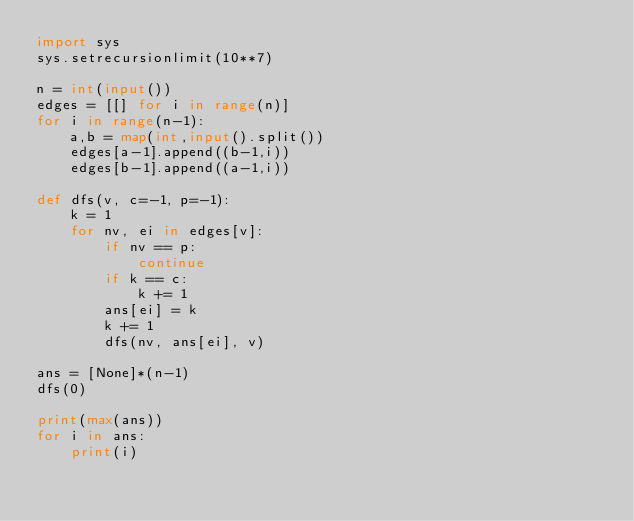Convert code to text. <code><loc_0><loc_0><loc_500><loc_500><_Python_>import sys
sys.setrecursionlimit(10**7)

n = int(input())
edges = [[] for i in range(n)]
for i in range(n-1):
    a,b = map(int,input().split())
    edges[a-1].append((b-1,i))
    edges[b-1].append((a-1,i))

def dfs(v, c=-1, p=-1):
    k = 1
    for nv, ei in edges[v]:
        if nv == p:
            continue
        if k == c:
            k += 1
        ans[ei] = k
        k += 1
        dfs(nv, ans[ei], v)

ans = [None]*(n-1)
dfs(0)

print(max(ans))
for i in ans:
    print(i)</code> 